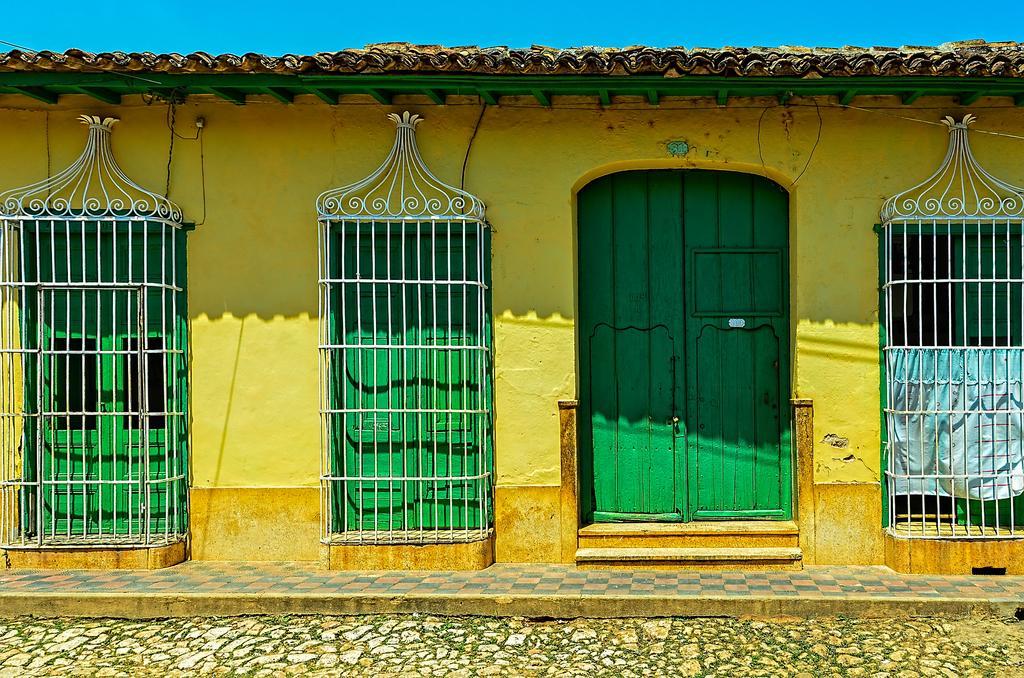Describe this image in one or two sentences. In this image we can see the yellow color wall and green color windows and doors. Here we can see the stone walkway. In the background, we can see the blue color sky. 